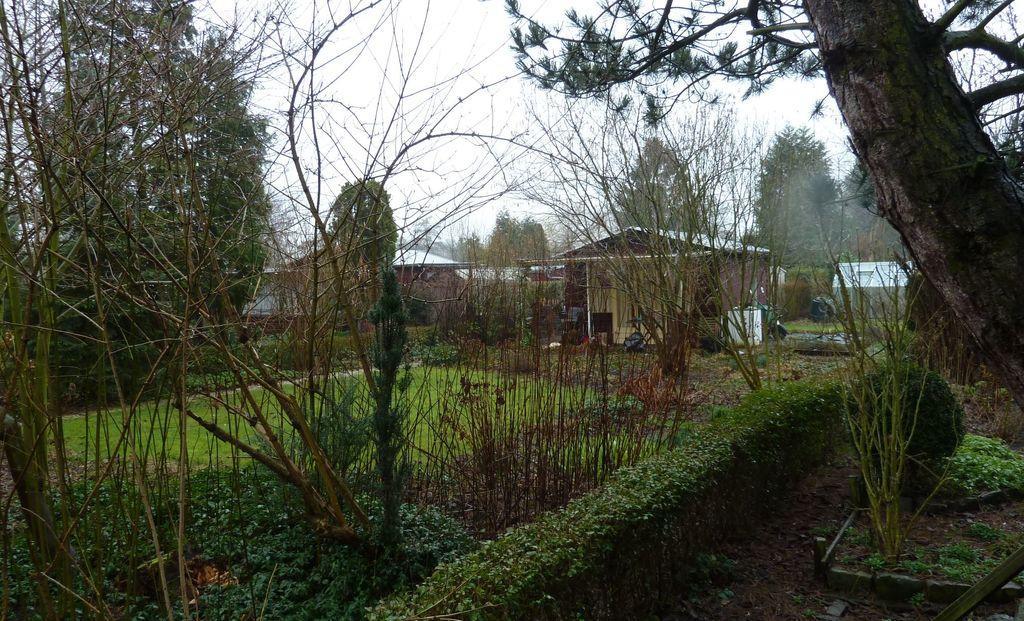Please provide a concise description of this image. In this image I can see there are trees, in the middle there are sheds, at the top it is the sky. 